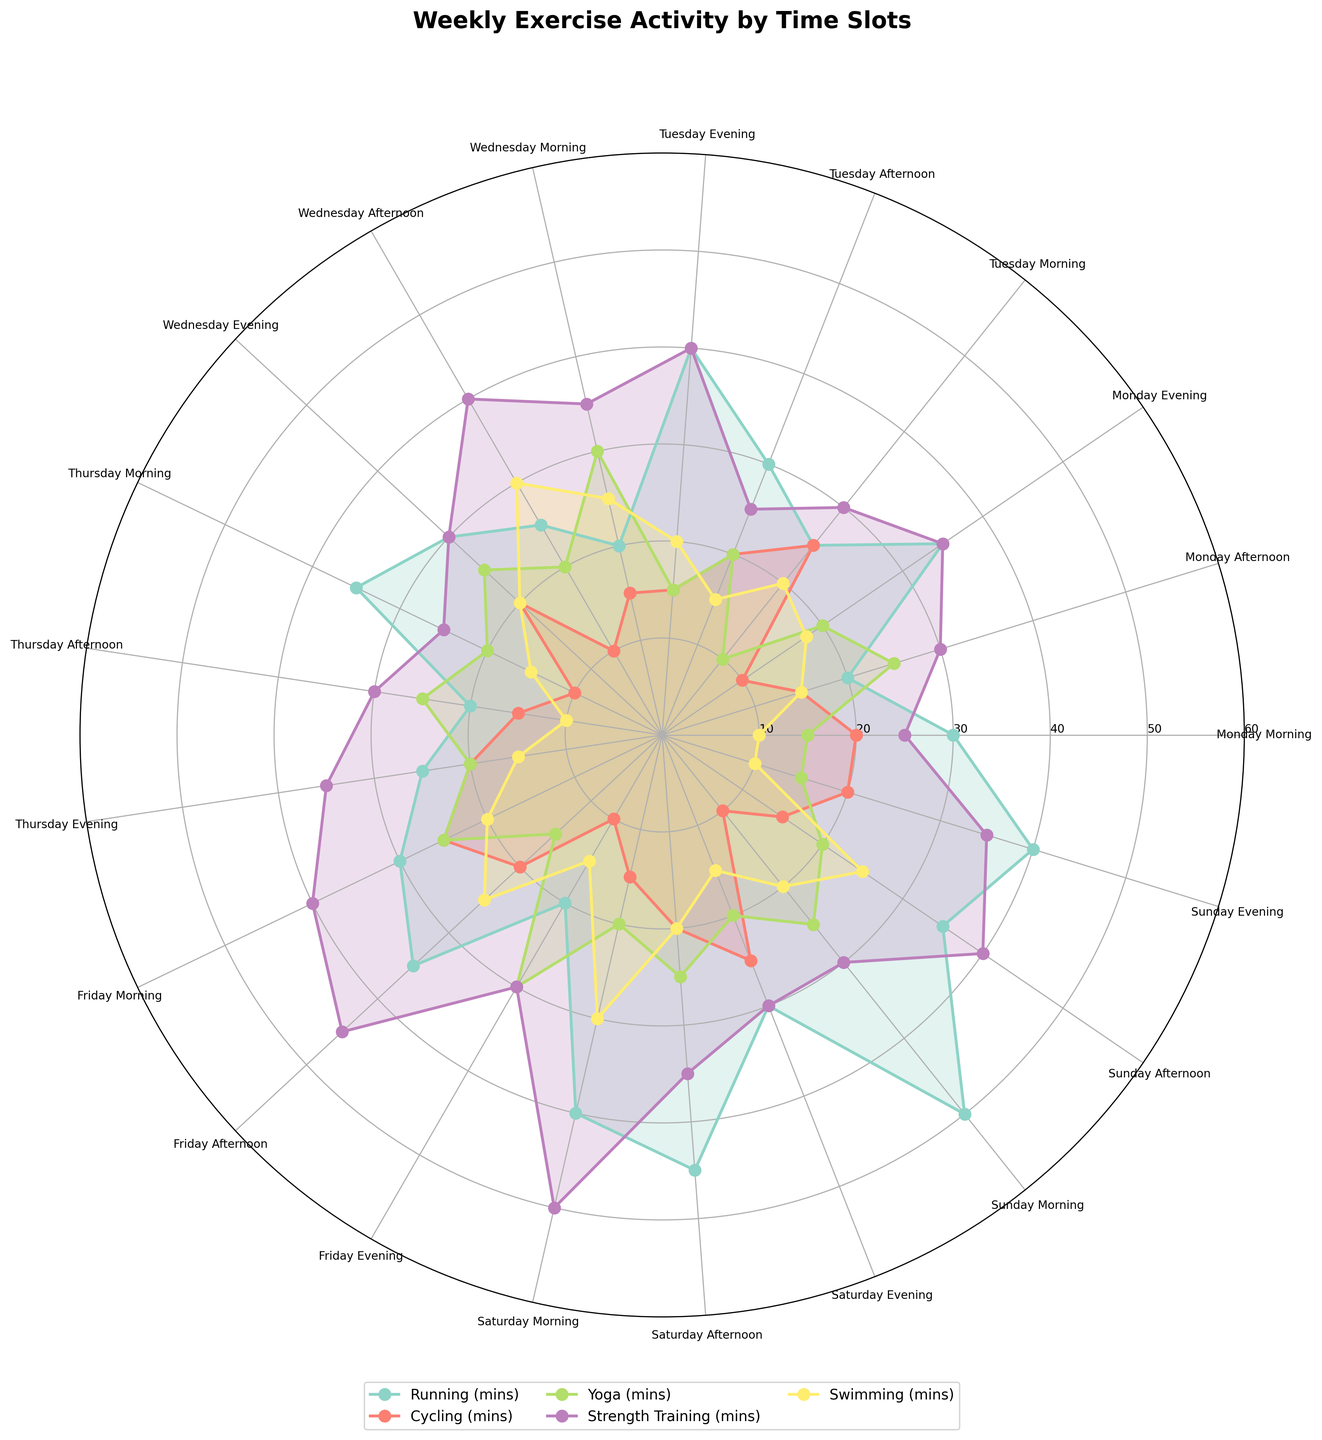What's the title of the figure? The title is typically located at the top of the plot. Check the top-center area of the figure for the text that represents the title.
Answer: Weekly Exercise Activity by Time Slots How many different exercise activities are displayed on the chart? Check the legend of the plot, which usually lists all the different exercise activities with corresponding colors. Count the number of distinct activities listed.
Answer: 5 Which exercise activity has the highest number of minutes on Sunday Morning? Identify the segment corresponding to Sunday Morning. Observe the lines and color-filled areas representing different activities. The highest peak in this segment indicates the activity with the highest number of minutes.
Answer: Running On which day and time slot is swimming performed the most? Follow the color line and filled area corresponding to Swimming. Check where this line reaches its maximum value on the radial axis and note the corresponding day and time slot from the radial labels.
Answer: Saturday Morning What is the longest duration for Yoga in the week? Look for the color representing Yoga. Trace the segments for each time slot to find the peak value for Yoga on the radial axis.
Answer: 30 minutes Compare the total minutes spent on Running on Monday and Tuesday. Which day has more minutes? Sum the Running minutes for each time slot on Monday (30 + 20 + 35) and on Tuesday (25 + 30 + 40). Compare the total values.
Answer: Tuesday Is there any day where Strength Training is consistently higher across all time slots compared to other days? Review the Strength Training line across all days and time slots. Compare its values to see if there's a day where it's relatively higher in all the slots.
Answer: No Calculate the average time spent on Cycling on Fridays. Take the Cycling times from Friday Morning, Afternoon, and Evening (25 + 20 + 10). Add them up and divide by 3.
Answer: 18.33 minutes Which time slot shows the highest variance in exercise activities? Look at each time slot segment and observe the spread of the lines. A larger spread indicates a higher variance. Identify the time slot with the widest range of values.
Answer: Saturday Morning Between Wednesday Afternoon and Thursday Evening, which time slot has more minutes of Strength Training? Compare the data points for Strength Training in these two slots by observing the radial axis values.
Answer: Wednesday Afternoon 